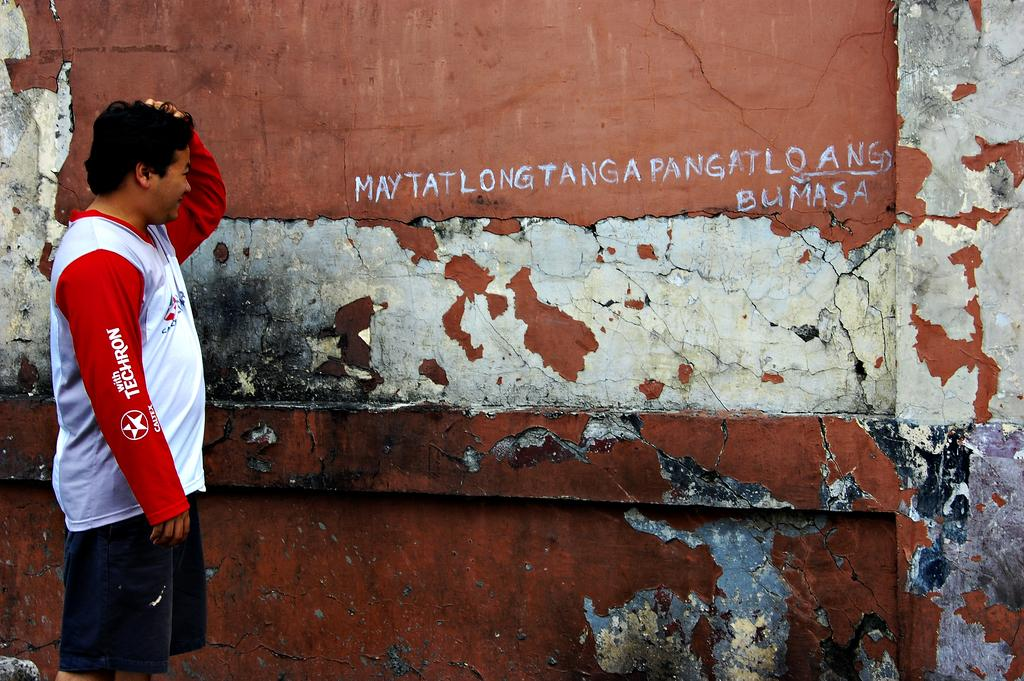<image>
Write a terse but informative summary of the picture. A amn looks at some grafiit on a derelict wall and is in a foreign language. 